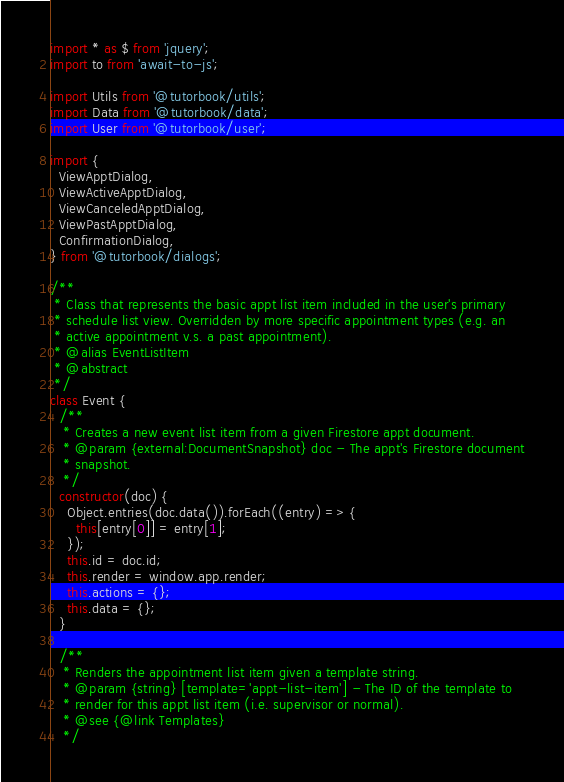<code> <loc_0><loc_0><loc_500><loc_500><_JavaScript_>
import * as $ from 'jquery';
import to from 'await-to-js';

import Utils from '@tutorbook/utils';
import Data from '@tutorbook/data';
import User from '@tutorbook/user';

import {
  ViewApptDialog,
  ViewActiveApptDialog,
  ViewCanceledApptDialog,
  ViewPastApptDialog,
  ConfirmationDialog,
} from '@tutorbook/dialogs';

/**
 * Class that represents the basic appt list item included in the user's primary
 * schedule list view. Overridden by more specific appointment types (e.g. an
 * active appointment v.s. a past appointment).
 * @alias EventListItem
 * @abstract
 */
class Event {
  /**
   * Creates a new event list item from a given Firestore appt document.
   * @param {external:DocumentSnapshot} doc - The appt's Firestore document
   * snapshot.
   */
  constructor(doc) {
    Object.entries(doc.data()).forEach((entry) => {
      this[entry[0]] = entry[1];
    });
    this.id = doc.id;
    this.render = window.app.render;
    this.actions = {};
    this.data = {};
  }

  /**
   * Renders the appointment list item given a template string.
   * @param {string} [template='appt-list-item'] - The ID of the template to
   * render for this appt list item (i.e. supervisor or normal).
   * @see {@link Templates}
   */</code> 